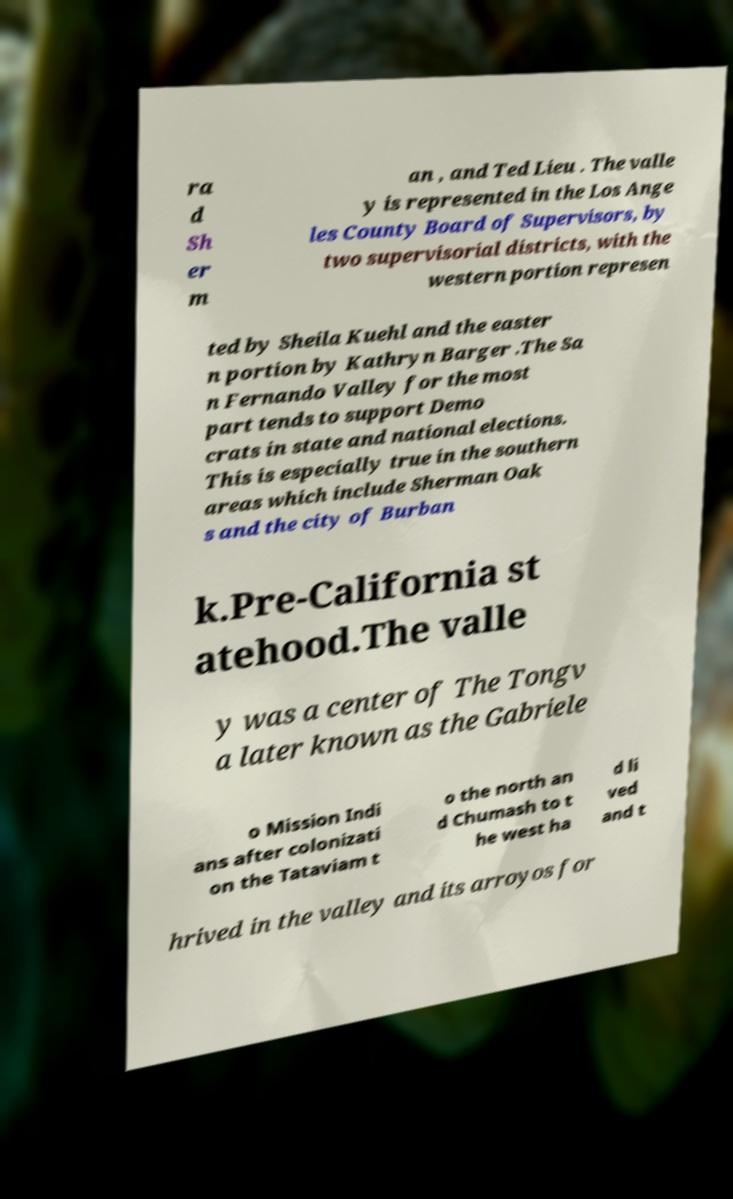I need the written content from this picture converted into text. Can you do that? ra d Sh er m an , and Ted Lieu . The valle y is represented in the Los Ange les County Board of Supervisors, by two supervisorial districts, with the western portion represen ted by Sheila Kuehl and the easter n portion by Kathryn Barger .The Sa n Fernando Valley for the most part tends to support Demo crats in state and national elections. This is especially true in the southern areas which include Sherman Oak s and the city of Burban k.Pre-California st atehood.The valle y was a center of The Tongv a later known as the Gabriele o Mission Indi ans after colonizati on the Tataviam t o the north an d Chumash to t he west ha d li ved and t hrived in the valley and its arroyos for 